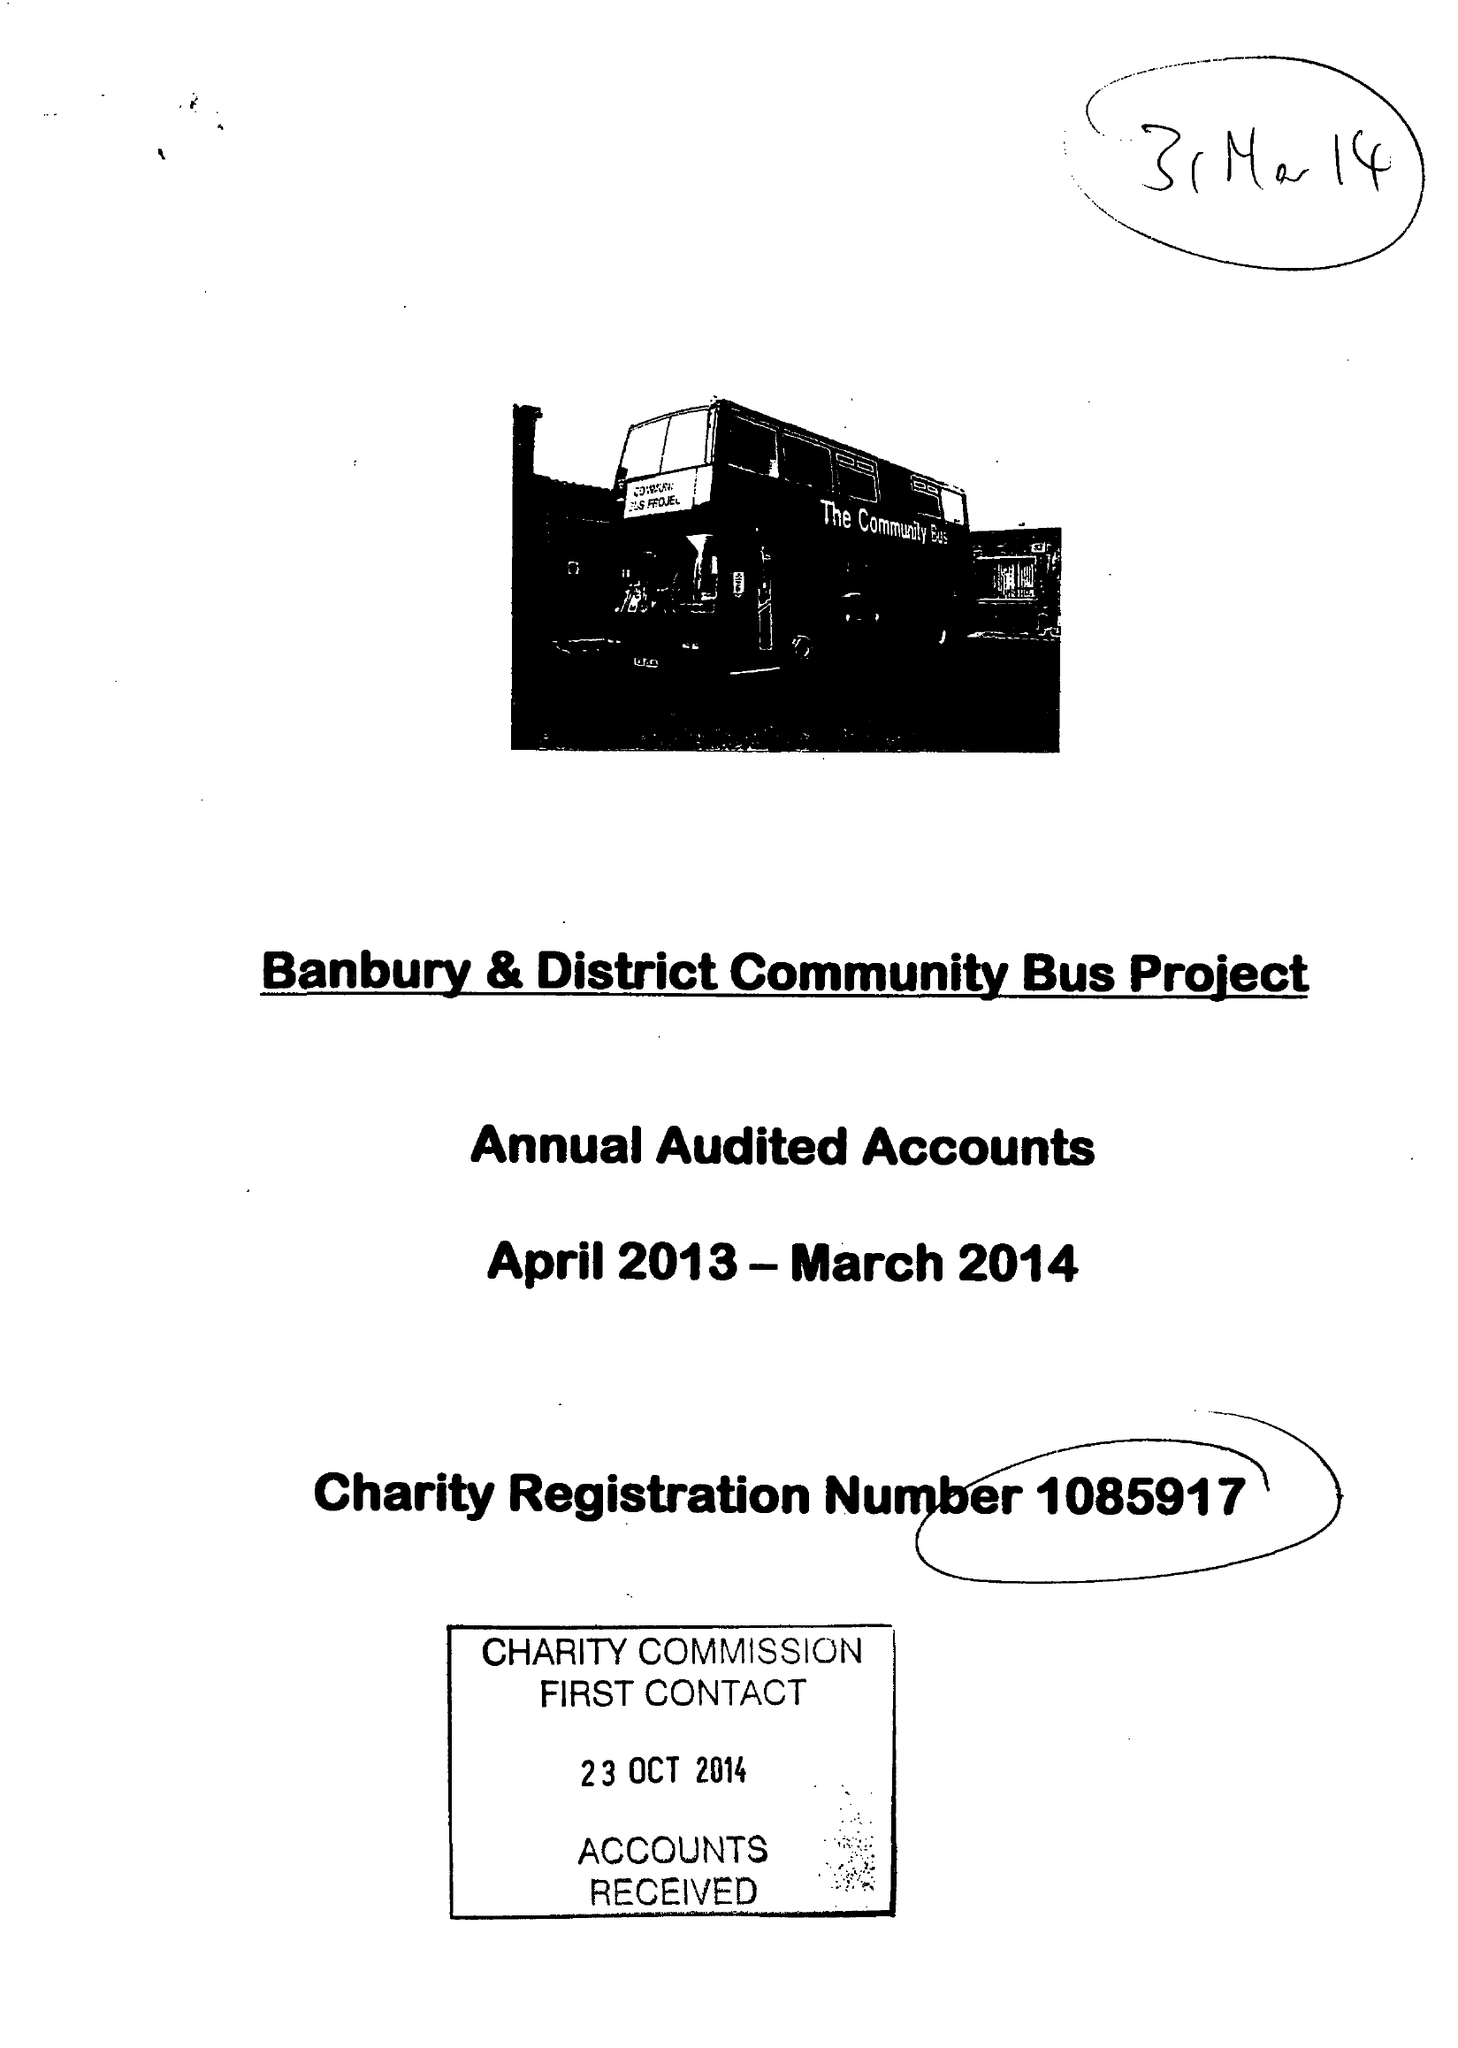What is the value for the address__postcode?
Answer the question using a single word or phrase. OX16 3WR 